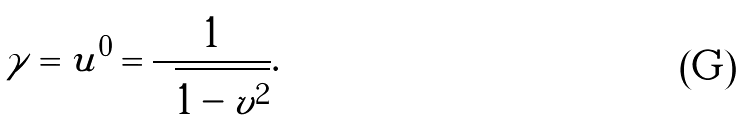Convert formula to latex. <formula><loc_0><loc_0><loc_500><loc_500>\gamma = u ^ { 0 } = \frac { 1 } { \sqrt { 1 - v ^ { 2 } } } .</formula> 